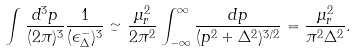<formula> <loc_0><loc_0><loc_500><loc_500>\int \frac { d ^ { 3 } p } { ( 2 \pi ) ^ { 3 } } \frac { 1 } { ( \epsilon ^ { - } _ { \Delta } ) ^ { 3 } } \simeq \frac { \mu _ { r } ^ { 2 } } { 2 \pi ^ { 2 } } \int _ { - \infty } ^ { \infty } \frac { d p } { ( p ^ { 2 } + \Delta ^ { 2 } ) ^ { 3 / 2 } } = \frac { \mu _ { r } ^ { 2 } } { \pi ^ { 2 } \Delta ^ { 2 } } .</formula> 